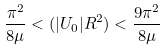Convert formula to latex. <formula><loc_0><loc_0><loc_500><loc_500>\frac { \pi ^ { 2 } } { 8 \mu } < ( | U _ { 0 } | R ^ { 2 } ) < \frac { 9 \pi ^ { 2 } } { 8 \mu }</formula> 